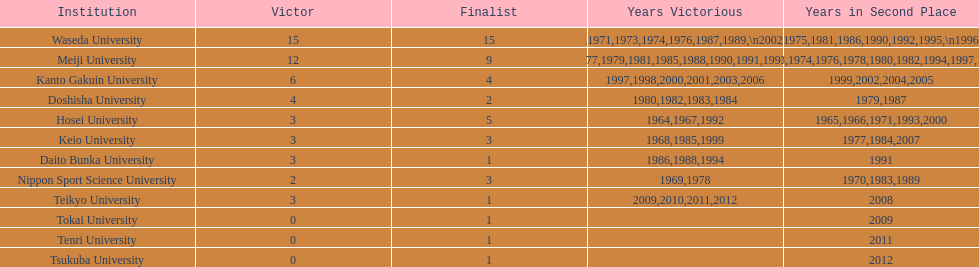Which university had the most years won? Waseda University. 